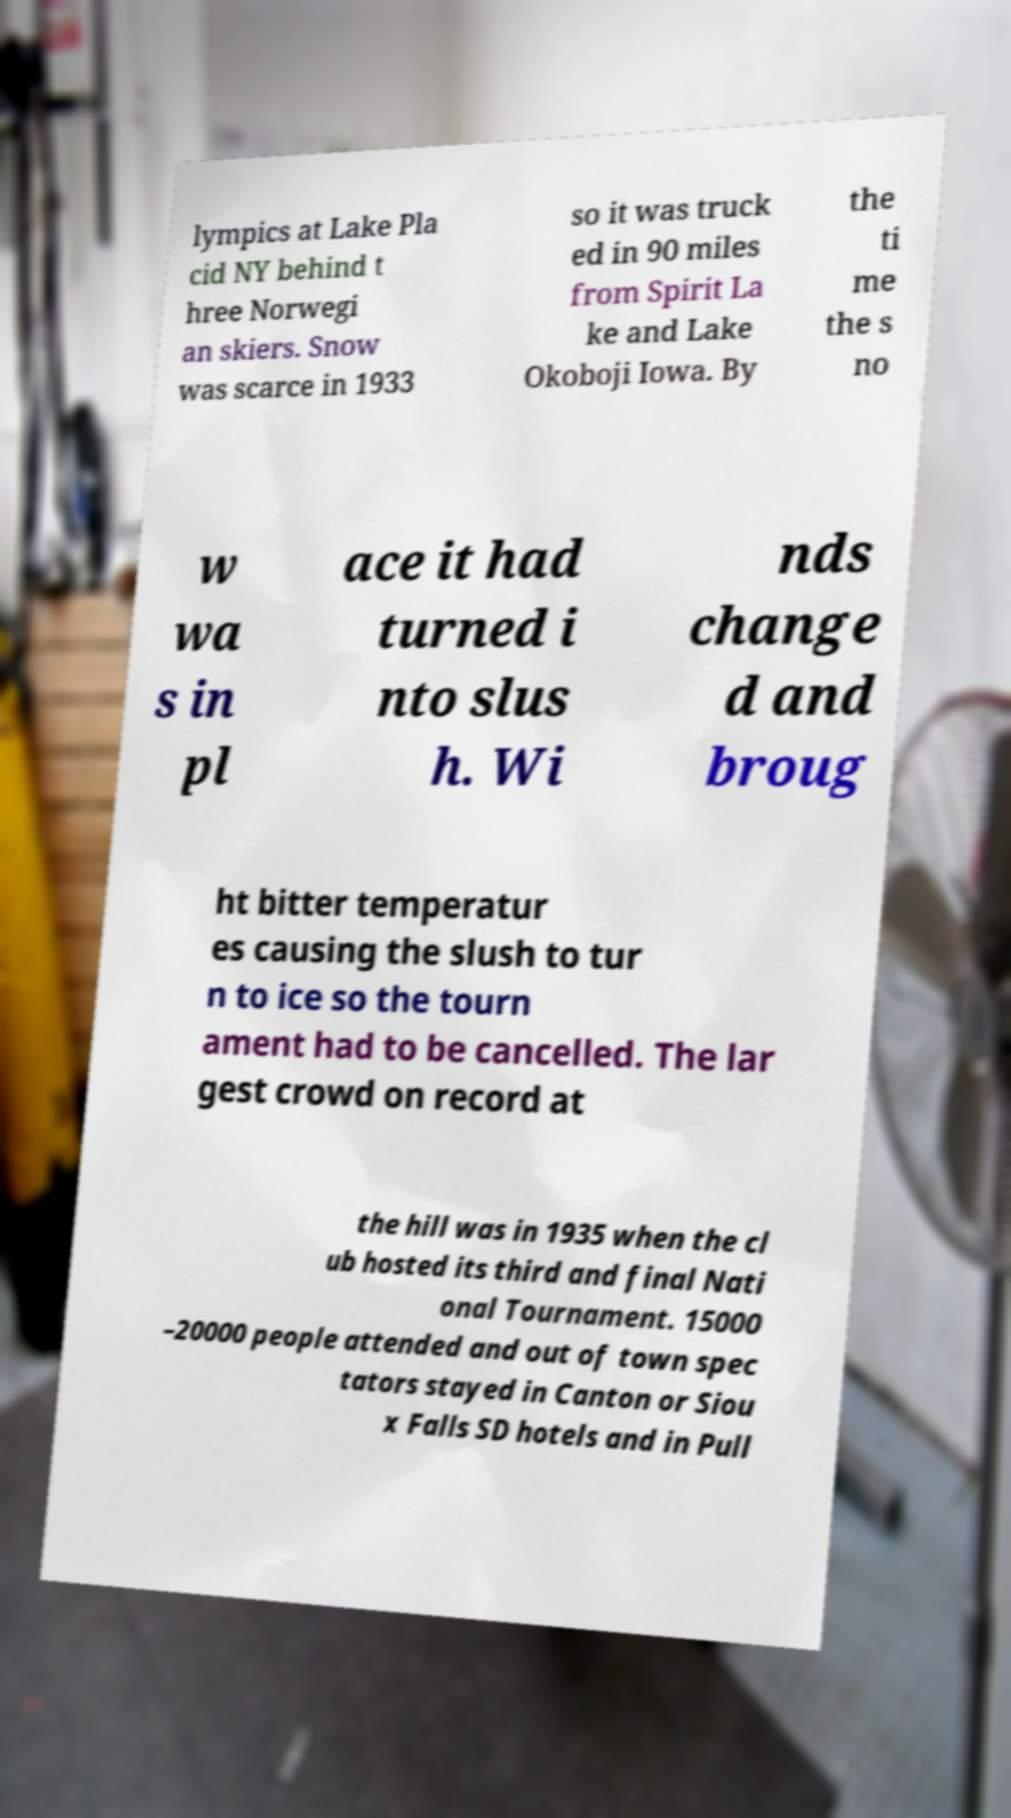For documentation purposes, I need the text within this image transcribed. Could you provide that? lympics at Lake Pla cid NY behind t hree Norwegi an skiers. Snow was scarce in 1933 so it was truck ed in 90 miles from Spirit La ke and Lake Okoboji Iowa. By the ti me the s no w wa s in pl ace it had turned i nto slus h. Wi nds change d and broug ht bitter temperatur es causing the slush to tur n to ice so the tourn ament had to be cancelled. The lar gest crowd on record at the hill was in 1935 when the cl ub hosted its third and final Nati onal Tournament. 15000 –20000 people attended and out of town spec tators stayed in Canton or Siou x Falls SD hotels and in Pull 